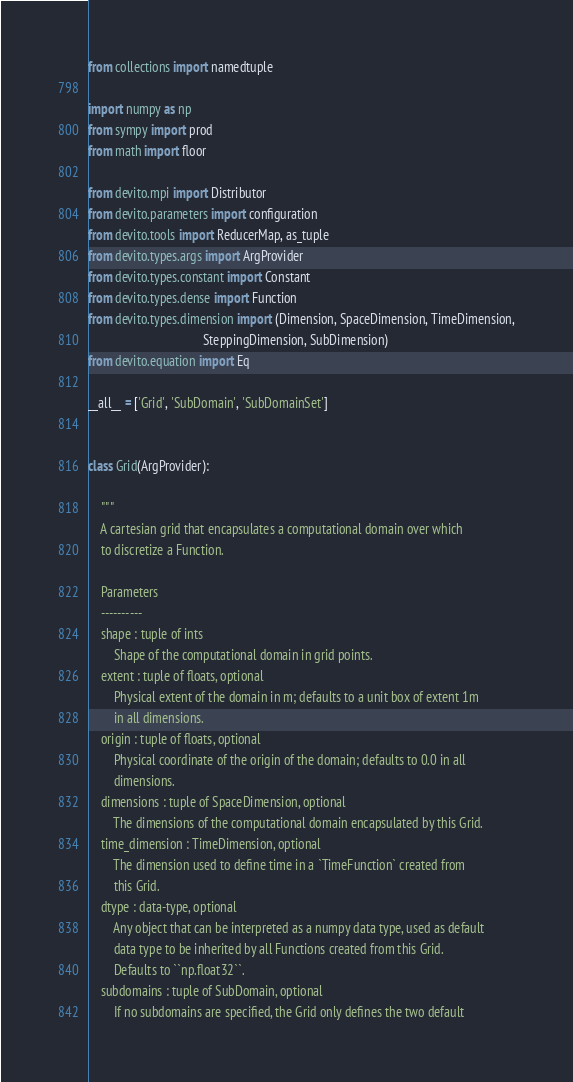Convert code to text. <code><loc_0><loc_0><loc_500><loc_500><_Python_>from collections import namedtuple

import numpy as np
from sympy import prod
from math import floor

from devito.mpi import Distributor
from devito.parameters import configuration
from devito.tools import ReducerMap, as_tuple
from devito.types.args import ArgProvider
from devito.types.constant import Constant
from devito.types.dense import Function
from devito.types.dimension import (Dimension, SpaceDimension, TimeDimension,
                                    SteppingDimension, SubDimension)
from devito.equation import Eq

__all__ = ['Grid', 'SubDomain', 'SubDomainSet']


class Grid(ArgProvider):

    """
    A cartesian grid that encapsulates a computational domain over which
    to discretize a Function.

    Parameters
    ----------
    shape : tuple of ints
        Shape of the computational domain in grid points.
    extent : tuple of floats, optional
        Physical extent of the domain in m; defaults to a unit box of extent 1m
        in all dimensions.
    origin : tuple of floats, optional
        Physical coordinate of the origin of the domain; defaults to 0.0 in all
        dimensions.
    dimensions : tuple of SpaceDimension, optional
        The dimensions of the computational domain encapsulated by this Grid.
    time_dimension : TimeDimension, optional
        The dimension used to define time in a `TimeFunction` created from
        this Grid.
    dtype : data-type, optional
        Any object that can be interpreted as a numpy data type, used as default
        data type to be inherited by all Functions created from this Grid.
        Defaults to ``np.float32``.
    subdomains : tuple of SubDomain, optional
        If no subdomains are specified, the Grid only defines the two default</code> 